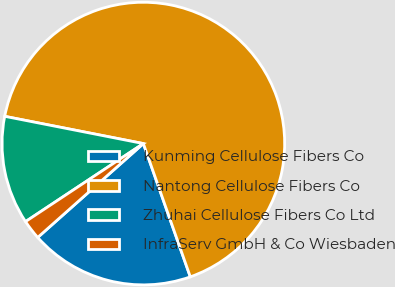<chart> <loc_0><loc_0><loc_500><loc_500><pie_chart><fcel>Kunming Cellulose Fibers Co<fcel>Nantong Cellulose Fibers Co<fcel>Zhuhai Cellulose Fibers Co Ltd<fcel>InfraServ GmbH & Co Wiesbaden<nl><fcel>18.83%<fcel>66.52%<fcel>12.4%<fcel>2.25%<nl></chart> 